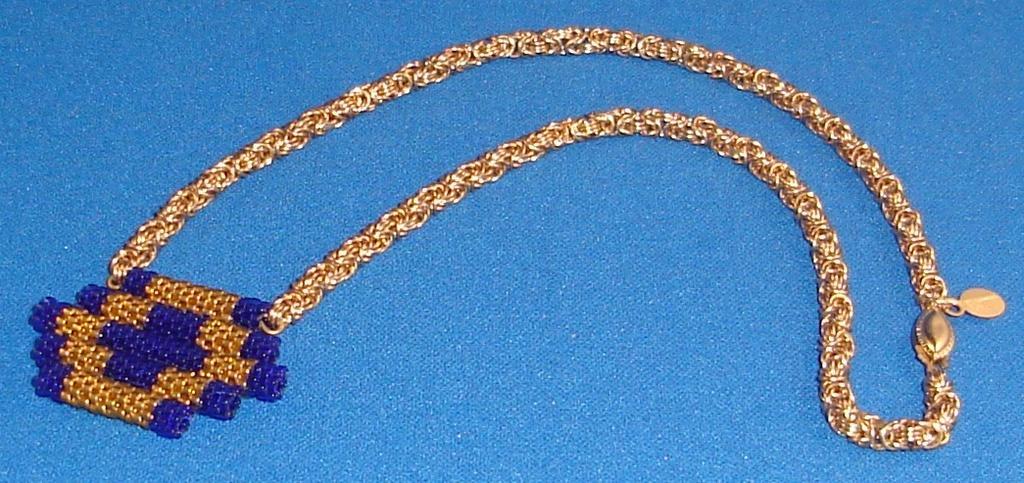Please provide a concise description of this image. In this image there is a chain on the surface. There is a pendant to the chain. 